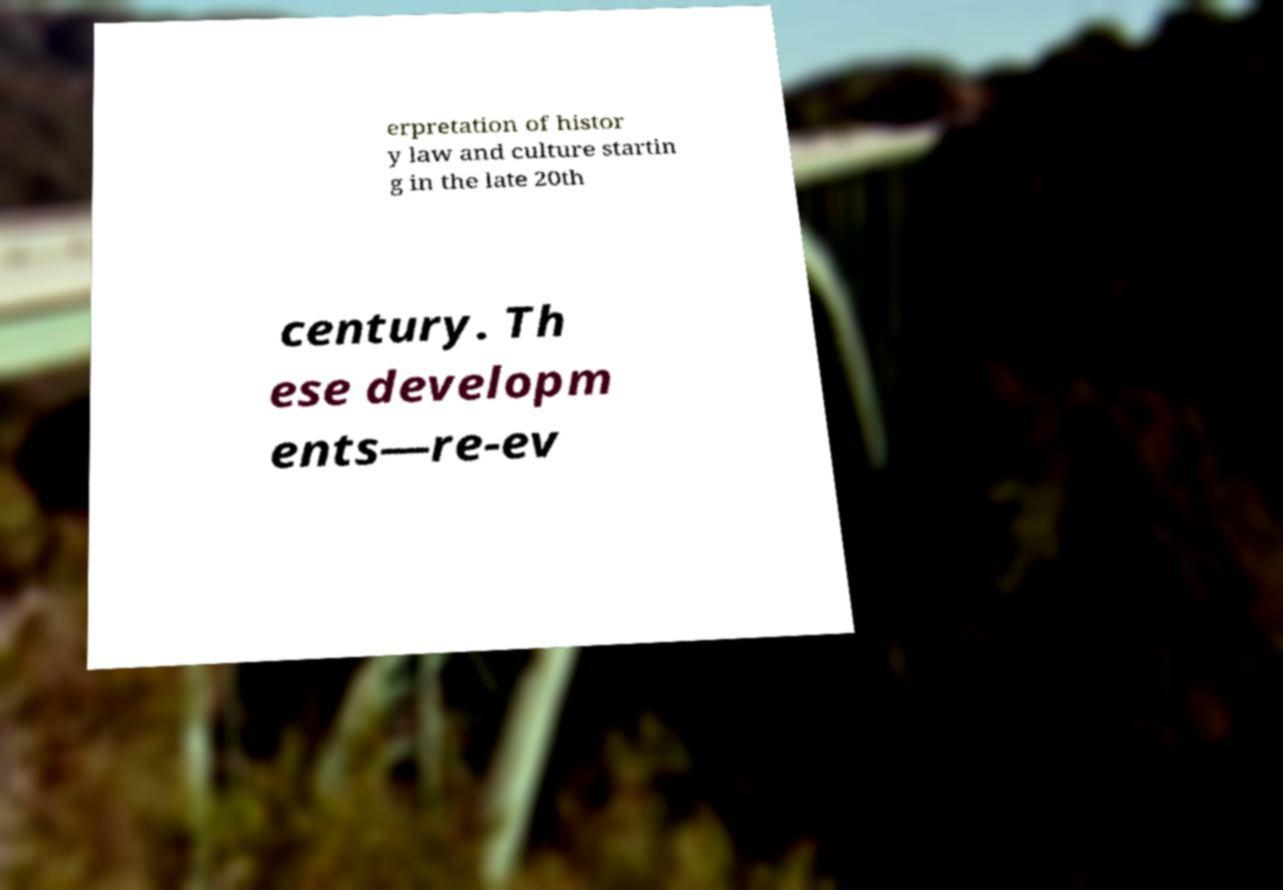What messages or text are displayed in this image? I need them in a readable, typed format. erpretation of histor y law and culture startin g in the late 20th century. Th ese developm ents—re-ev 